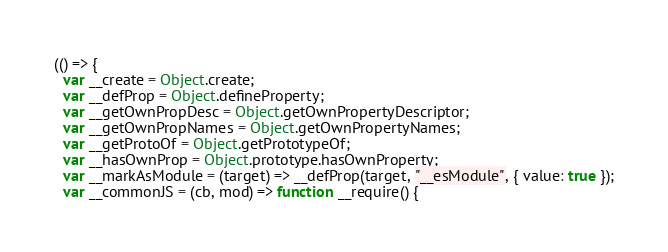Convert code to text. <code><loc_0><loc_0><loc_500><loc_500><_JavaScript_>(() => {
  var __create = Object.create;
  var __defProp = Object.defineProperty;
  var __getOwnPropDesc = Object.getOwnPropertyDescriptor;
  var __getOwnPropNames = Object.getOwnPropertyNames;
  var __getProtoOf = Object.getPrototypeOf;
  var __hasOwnProp = Object.prototype.hasOwnProperty;
  var __markAsModule = (target) => __defProp(target, "__esModule", { value: true });
  var __commonJS = (cb, mod) => function __require() {</code> 